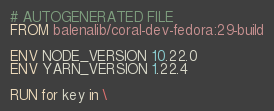<code> <loc_0><loc_0><loc_500><loc_500><_Dockerfile_># AUTOGENERATED FILE
FROM balenalib/coral-dev-fedora:29-build

ENV NODE_VERSION 10.22.0
ENV YARN_VERSION 1.22.4

RUN for key in \</code> 